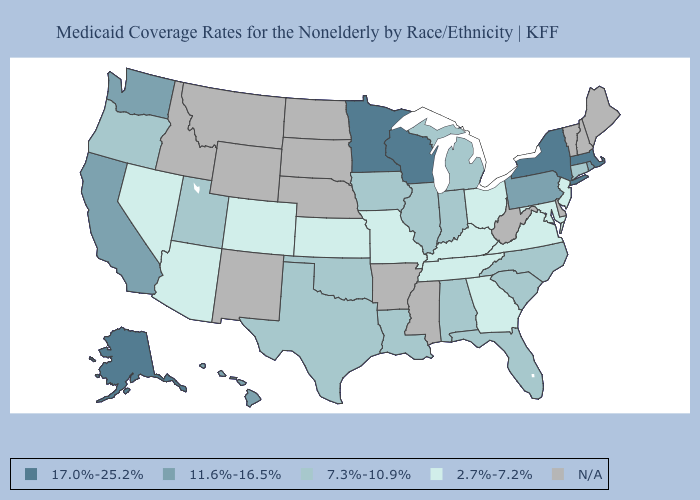Among the states that border Colorado , which have the lowest value?
Quick response, please. Arizona, Kansas. Among the states that border Oregon , does Washington have the highest value?
Give a very brief answer. Yes. What is the value of Hawaii?
Be succinct. 11.6%-16.5%. Does Illinois have the lowest value in the MidWest?
Quick response, please. No. What is the value of Mississippi?
Answer briefly. N/A. Does Massachusetts have the highest value in the Northeast?
Concise answer only. Yes. What is the value of Vermont?
Give a very brief answer. N/A. What is the value of Kentucky?
Keep it brief. 2.7%-7.2%. Does the first symbol in the legend represent the smallest category?
Quick response, please. No. Among the states that border Arkansas , which have the highest value?
Concise answer only. Louisiana, Oklahoma, Texas. What is the value of Oregon?
Concise answer only. 7.3%-10.9%. Which states have the lowest value in the MidWest?
Concise answer only. Kansas, Missouri, Ohio. Does the first symbol in the legend represent the smallest category?
Give a very brief answer. No. 